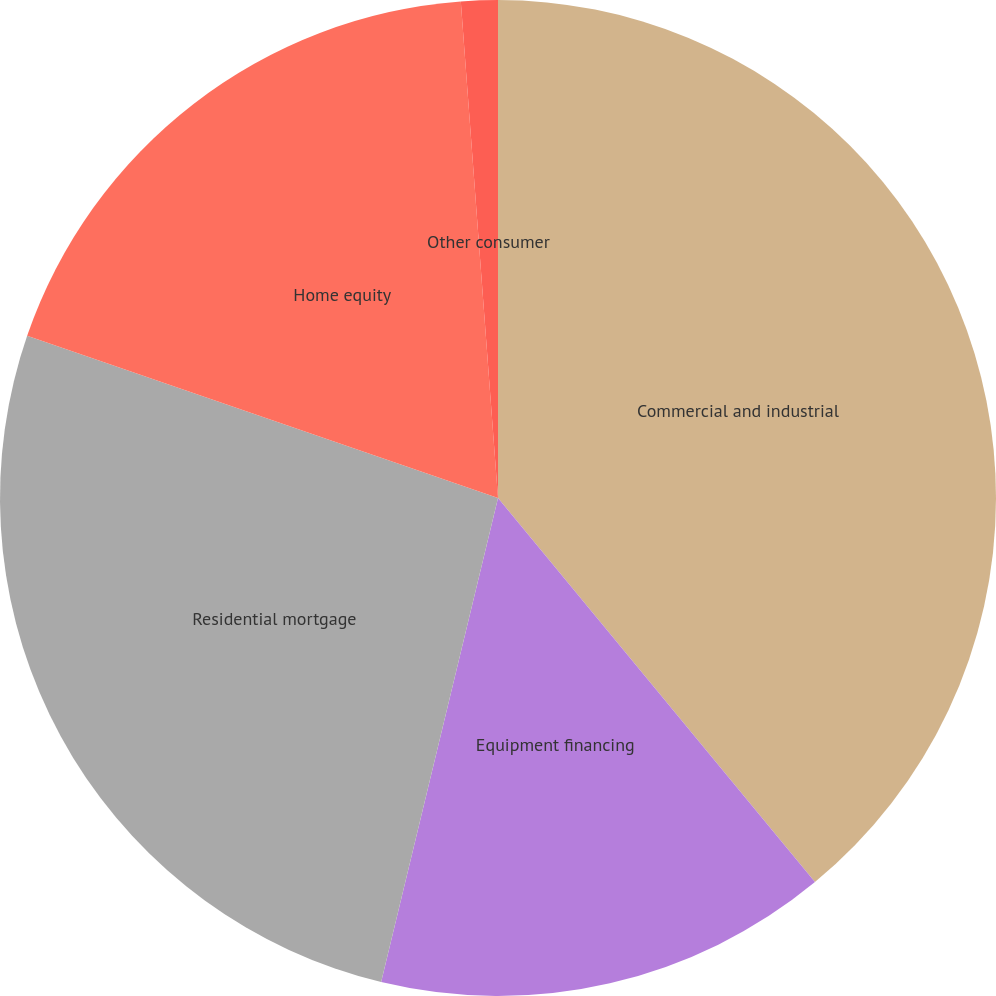Convert chart. <chart><loc_0><loc_0><loc_500><loc_500><pie_chart><fcel>Commercial and industrial<fcel>Equipment financing<fcel>Residential mortgage<fcel>Home equity<fcel>Other consumer<nl><fcel>39.02%<fcel>14.75%<fcel>26.51%<fcel>18.53%<fcel>1.19%<nl></chart> 